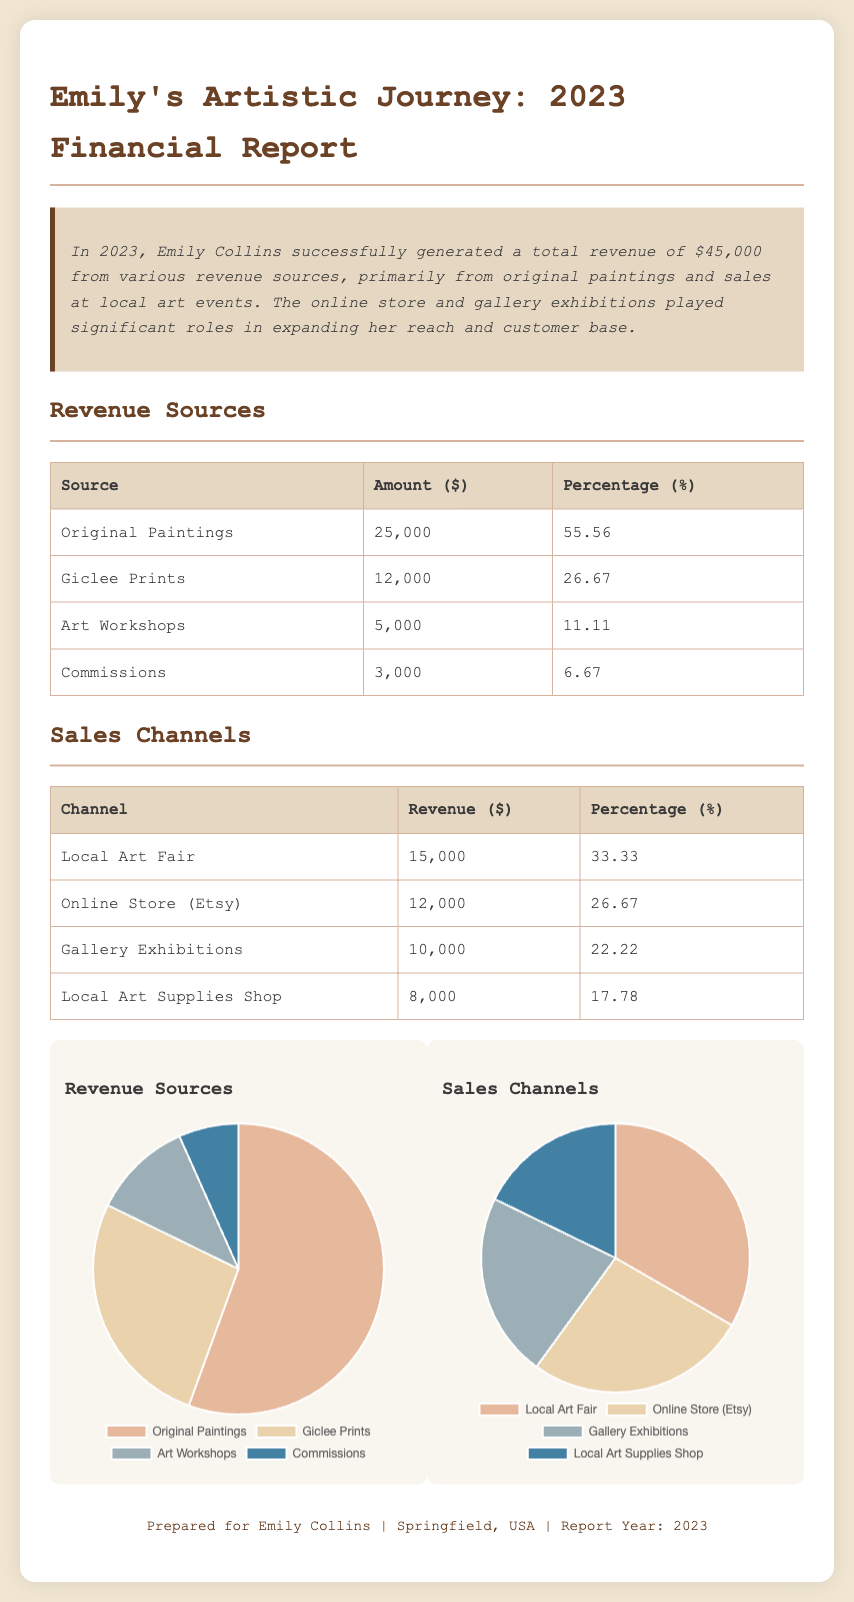what is the total revenue? The total revenue is mentioned in the summary of the document, which states that it is $45,000.
Answer: $45,000 how much was earned from original paintings? The revenue table specifies that $25,000 was earned from original paintings.
Answer: $25,000 what percentage of total revenue comes from giclee prints? The revenue table shows that giclee prints contributed 26.67% to the total revenue.
Answer: 26.67% which sales channel generated the highest revenue? The sales channel table lists the local art fair as having the highest revenue at $15,000.
Answer: Local Art Fair how much revenue was generated from art workshops? According to the revenue sources table, $5,000 was generated from art workshops.
Answer: $5,000 which sales channel contributed 22.22% to the revenue? The document specifies that gallery exhibitions contributed 22.22% to the total revenue.
Answer: Gallery Exhibitions what is the percentage contribution of commissions to total revenue? The revenue sources table indicates that commissions contributed 6.67% to the total revenue.
Answer: 6.67% how much revenue did the online store generate? The sales channels table mentions that the online store (Etsy) generated $12,000.
Answer: $12,000 what is the total percentage from all revenue sources listed? Since all percentages in the revenue sources add up to 100%, the total percentage is 100%.
Answer: 100% 